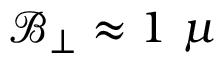<formula> <loc_0><loc_0><loc_500><loc_500>\mathcal { B } _ { \perp } \approx 1 \mu</formula> 